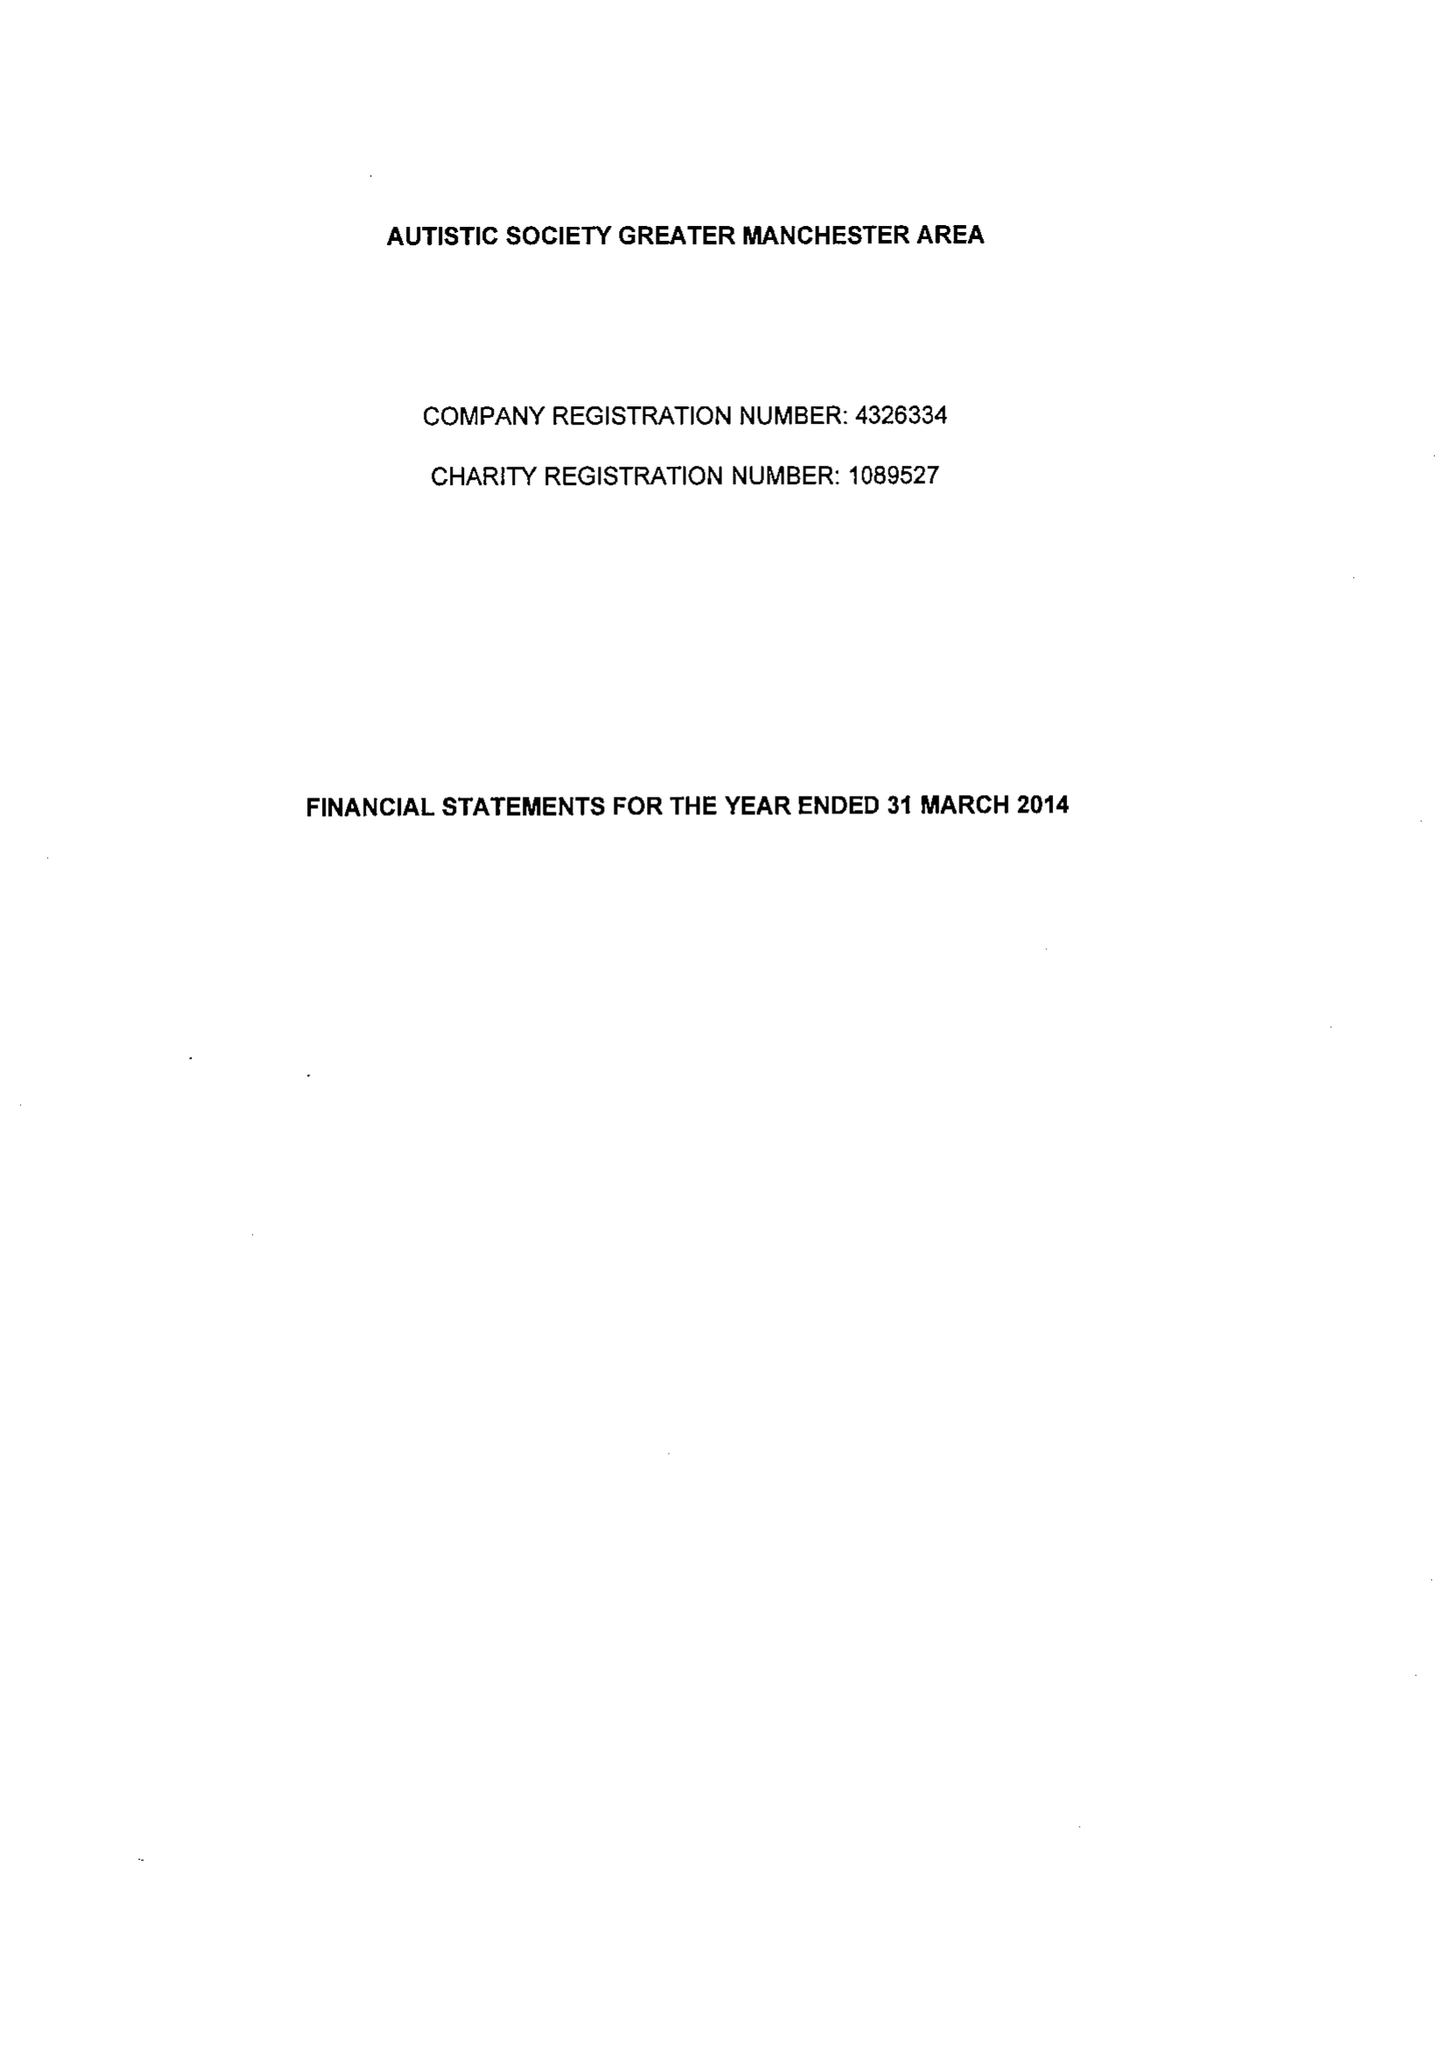What is the value for the address__street_line?
Answer the question using a single word or phrase. 1114 CHESTER ROAD 